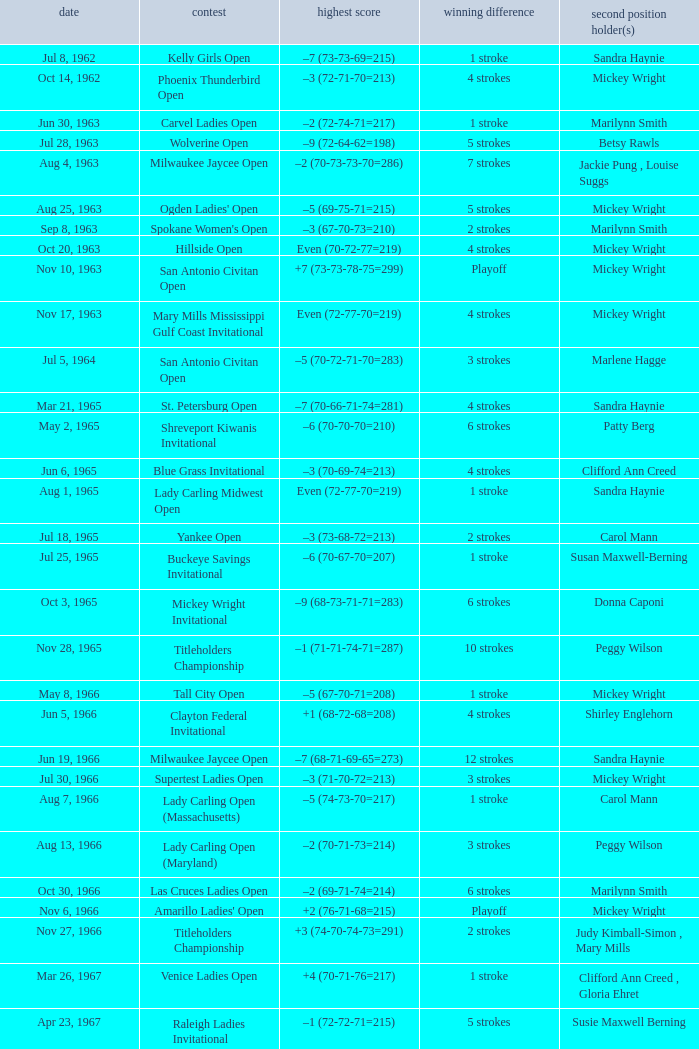What was the winning score when there were 9 strokes advantage? –7 (73-68-73-67=281). 